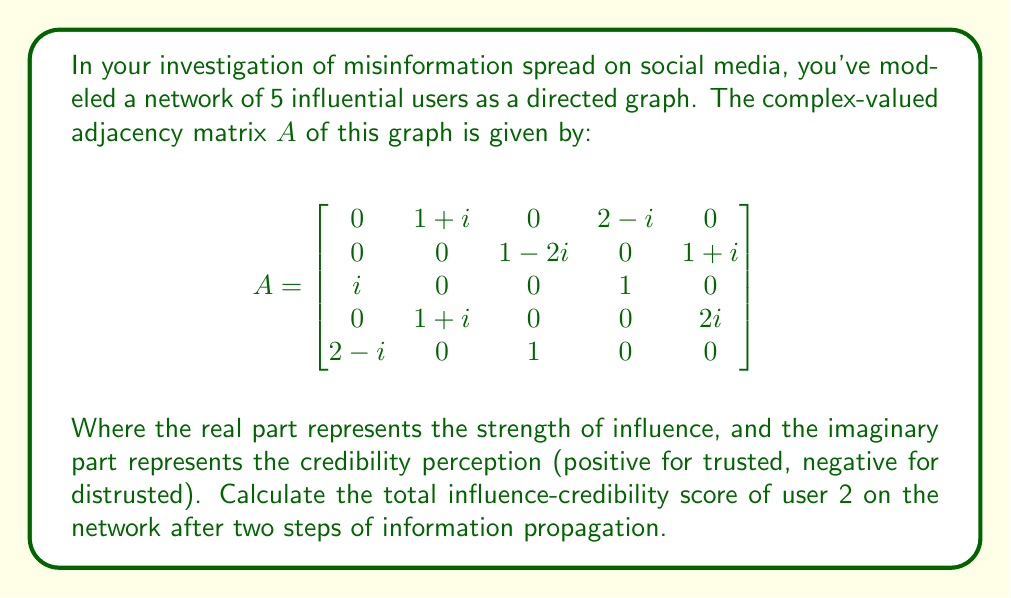Can you solve this math problem? To solve this problem, we need to understand that the influence-credibility score after two steps is represented by the sum of the elements in the second row of $A^2$.

Step 1: Calculate $A^2$
$$A^2 = A \times A$$

Step 2: Multiply the matrices
(For brevity, we'll focus on the second row of the result)

Row 2 of $A^2$:
$$(0\cdot(1+i) + 0\cdot(1-2i) + (1-2i)\cdot i + 0\cdot(1+i) + (1+i)\cdot(2-i),$$
$$0\cdot 0 + 0\cdot 0 + (1-2i)\cdot 0 + 0\cdot(1+i) + (1+i)\cdot 0,$$
$$0\cdot 0 + 0\cdot(1-2i) + (1-2i)\cdot 0 + 0\cdot 0 + (1+i)\cdot 1,$$
$$0\cdot(2-i) + 0\cdot 0 + (1-2i)\cdot 1 + 0\cdot 0 + (1+i)\cdot 0,$$
$$0\cdot 0 + 0\cdot(1+i) + (1-2i)\cdot 0 + 0\cdot 2i + (1+i)\cdot 0)$$

Step 3: Simplify each term
$$(1-2i)(i) + (1+i)(2-i) = 2+i + 3+i = 5+2i$$
$$(1+i)(1) = 1+i$$
$$(1-2i)(1) = 1-2i$$

Step 4: Sum up all non-zero terms
Total influence-credibility score = $(5+2i) + (1+i) + (1-2i) = 7+i$

The real part (7) represents the total strength of influence, while the imaginary part (1) represents the net credibility perception after two steps of propagation.
Answer: $7+i$ 